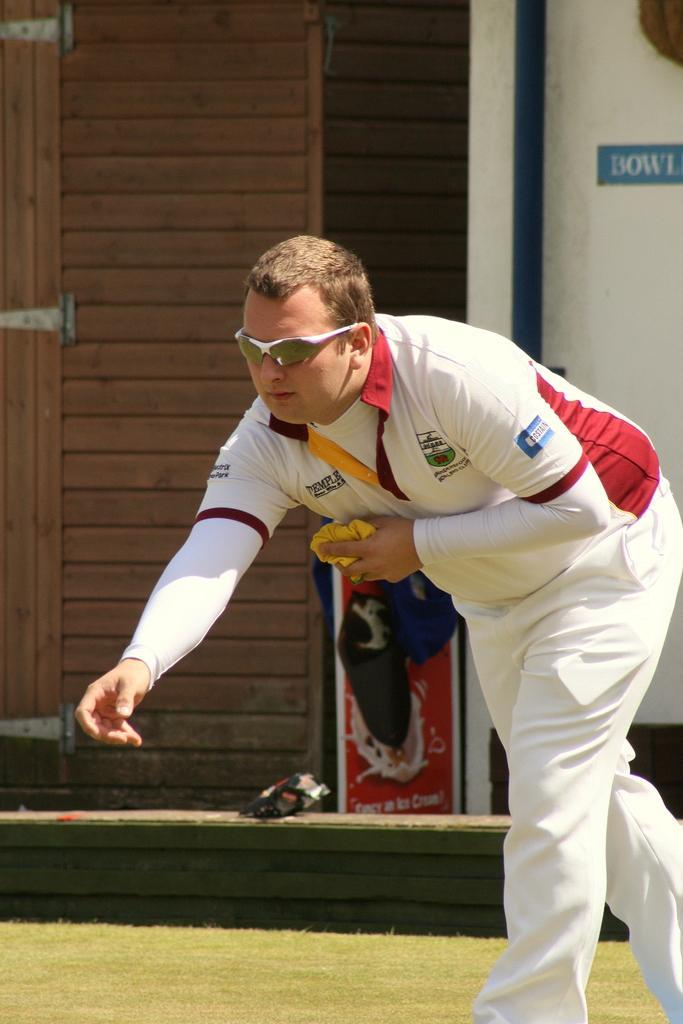Please provide a concise description of this image. In this image we can see a man standing on the ground holding a cloth. We can also see some grass, a wooden door and a board on a wall. 